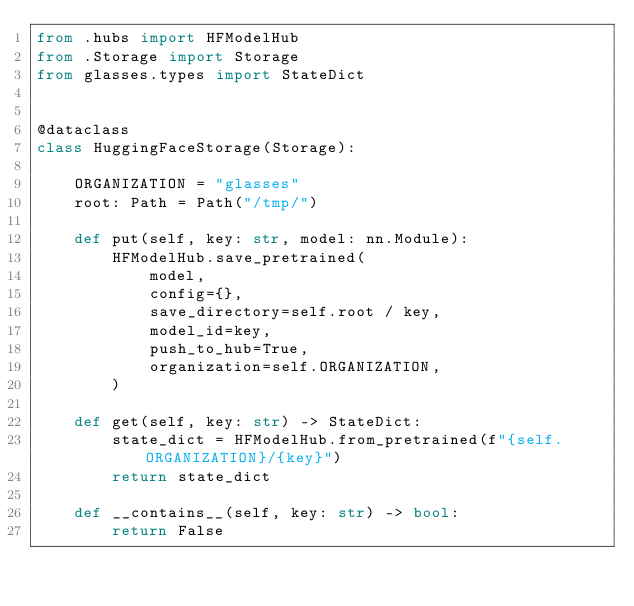<code> <loc_0><loc_0><loc_500><loc_500><_Python_>from .hubs import HFModelHub
from .Storage import Storage
from glasses.types import StateDict


@dataclass
class HuggingFaceStorage(Storage):

    ORGANIZATION = "glasses"
    root: Path = Path("/tmp/")

    def put(self, key: str, model: nn.Module):
        HFModelHub.save_pretrained(
            model,
            config={},
            save_directory=self.root / key,
            model_id=key,
            push_to_hub=True,
            organization=self.ORGANIZATION,
        )

    def get(self, key: str) -> StateDict:
        state_dict = HFModelHub.from_pretrained(f"{self.ORGANIZATION}/{key}")
        return state_dict

    def __contains__(self, key: str) -> bool:
        return False
</code> 